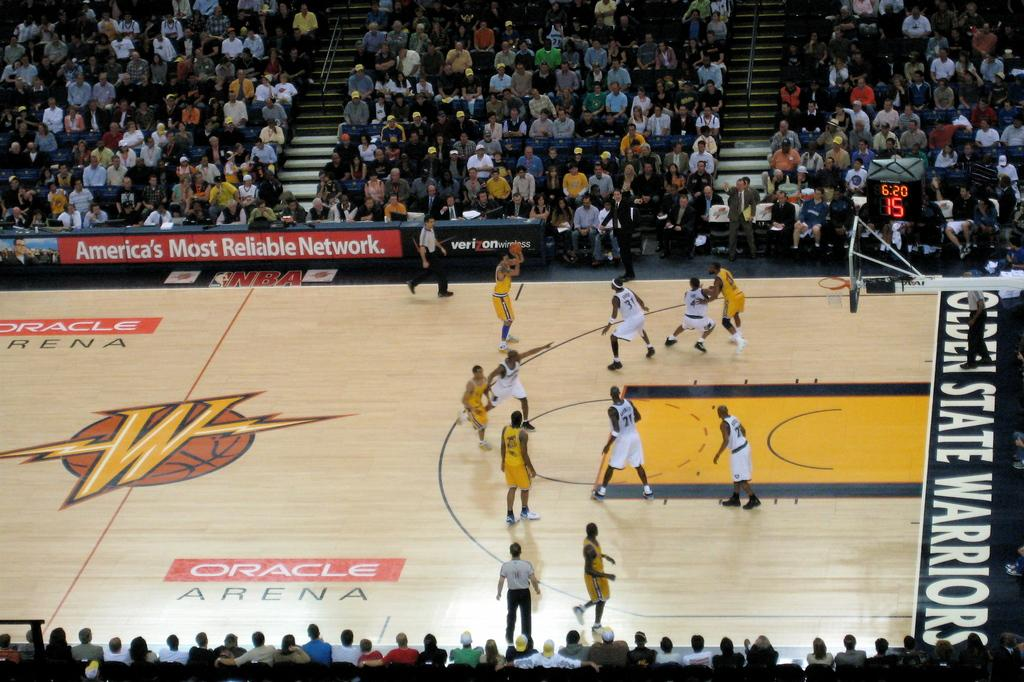<image>
Relay a brief, clear account of the picture shown. A basketball game at Oracle Arena with a big W in the middle of the court. 